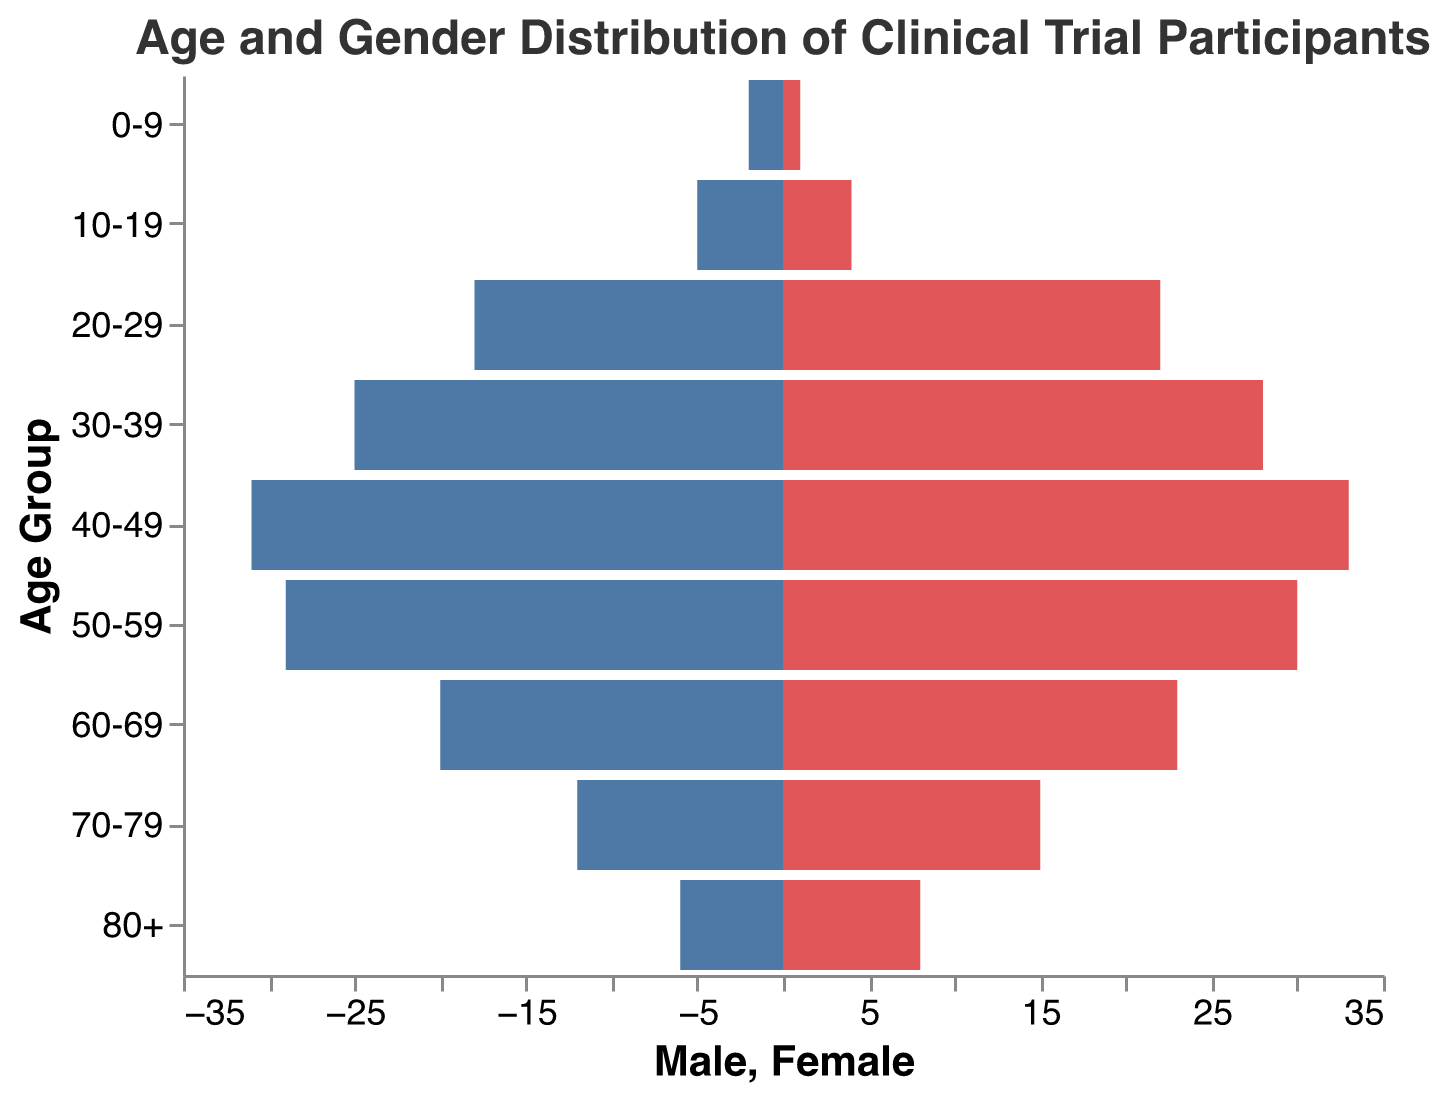What is the title of the figure? The title of the figure is located at the top and usually in a larger font size. It provides a succinct description of what the chart is about.
Answer: Age and Gender Distribution of Clinical Trial Participants What are the age groups used in the figure? The age groups are listed on the vertical axis (y-axis) and represent the classification of participants by age range.
Answer: 0-9, 10-19, 20-29, 30-39, 40-49, 50-59, 60-69, 70-79, 80+ Which gender has the highest count in the 40-49 age group? To determine this, compare the bar lengths for "Male" and "Female" within the 40-49 age group. The longer bar will indicate the gender with the higher count.
Answer: Female How many males are there in the 60-69 age group? Look at the length of the blue bar for the 60-69 age group. The value represents the count of male participants.
Answer: 20 How many total participants are in the 30-39 age group? Sum the male and female counts for the 30-39 age group. Male (25) + Female (28) = 53
Answer: 53 What is the difference in the number of participants between males and females in the 20-29 age group? Subtract the number of males from the number of females for the 20-29 age group. Female (22) - Male (18) = 4
Answer: 4 Which age group has the smallest number of female participants? Compare the lengths of the red bars (females) across all age groups. The shortest bar represents the group with the smallest number.
Answer: 0-9 Are there more male or female participants in the 50-59 age group? Compare the lengths of the bars for males and females in the 50-59 age group. The longer bar indicates the gender with more participants.
Answer: Female Which gender generally has higher participation in clinical trials across the age groups shown? By observing the lengths of the bars across all age groups, determine which gender tends to have longer bars overall.
Answer: Female How many participants are in the 70-79 age group altogether? Add the number of males and females in the 70-79 age group. Male (12) + Female (15) = 27
Answer: 27 